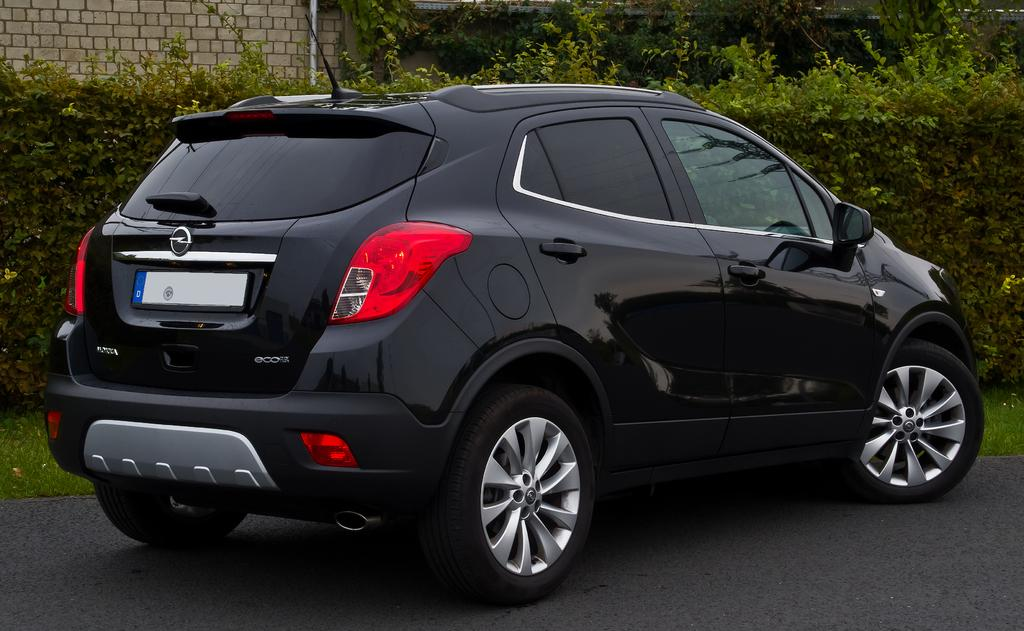What is the main subject of the image? There is a car on the road in the image. What can be seen in the background of the image? There are plants, grass, a wall, and a pole in the background of the image. What type of knee injury can be seen in the image? There is no knee injury present in the image; it features a car on the road and various elements in the background. What kind of pot is visible in the image? There is no pot present in the image. 